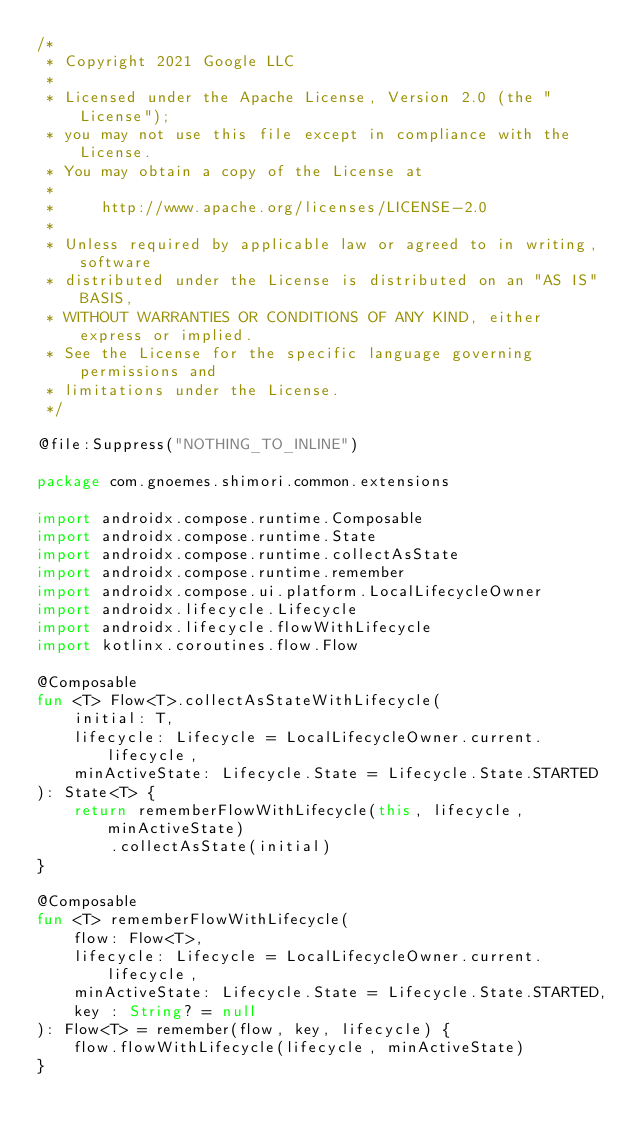<code> <loc_0><loc_0><loc_500><loc_500><_Kotlin_>/*
 * Copyright 2021 Google LLC
 *
 * Licensed under the Apache License, Version 2.0 (the "License");
 * you may not use this file except in compliance with the License.
 * You may obtain a copy of the License at
 *
 *     http://www.apache.org/licenses/LICENSE-2.0
 *
 * Unless required by applicable law or agreed to in writing, software
 * distributed under the License is distributed on an "AS IS" BASIS,
 * WITHOUT WARRANTIES OR CONDITIONS OF ANY KIND, either express or implied.
 * See the License for the specific language governing permissions and
 * limitations under the License.
 */

@file:Suppress("NOTHING_TO_INLINE")

package com.gnoemes.shimori.common.extensions

import androidx.compose.runtime.Composable
import androidx.compose.runtime.State
import androidx.compose.runtime.collectAsState
import androidx.compose.runtime.remember
import androidx.compose.ui.platform.LocalLifecycleOwner
import androidx.lifecycle.Lifecycle
import androidx.lifecycle.flowWithLifecycle
import kotlinx.coroutines.flow.Flow

@Composable
fun <T> Flow<T>.collectAsStateWithLifecycle(
    initial: T,
    lifecycle: Lifecycle = LocalLifecycleOwner.current.lifecycle,
    minActiveState: Lifecycle.State = Lifecycle.State.STARTED
): State<T> {
    return rememberFlowWithLifecycle(this, lifecycle, minActiveState)
        .collectAsState(initial)
}

@Composable
fun <T> rememberFlowWithLifecycle(
    flow: Flow<T>,
    lifecycle: Lifecycle = LocalLifecycleOwner.current.lifecycle,
    minActiveState: Lifecycle.State = Lifecycle.State.STARTED,
    key : String? = null
): Flow<T> = remember(flow, key, lifecycle) {
    flow.flowWithLifecycle(lifecycle, minActiveState)
}</code> 